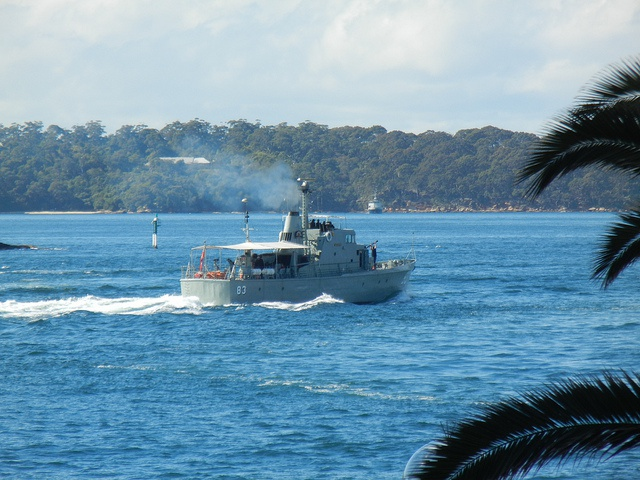Describe the objects in this image and their specific colors. I can see boat in lightgray, blue, gray, and lightblue tones, boat in lightgray, gray, and darkgray tones, and people in lightgray, black, navy, blue, and gray tones in this image. 